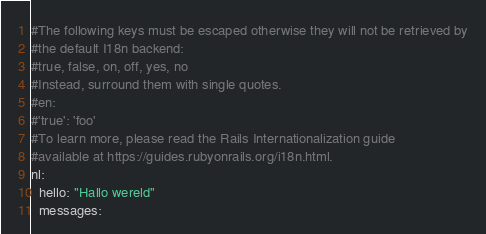Convert code to text. <code><loc_0><loc_0><loc_500><loc_500><_YAML_>#The following keys must be escaped otherwise they will not be retrieved by
#the default I18n backend:
#true, false, on, off, yes, no
#Instead, surround them with single quotes.
#en:
#'true': 'foo'
#To learn more, please read the Rails Internationalization guide
#available at https://guides.rubyonrails.org/i18n.html.
nl:
  hello: "Hallo wereld"
  messages:</code> 